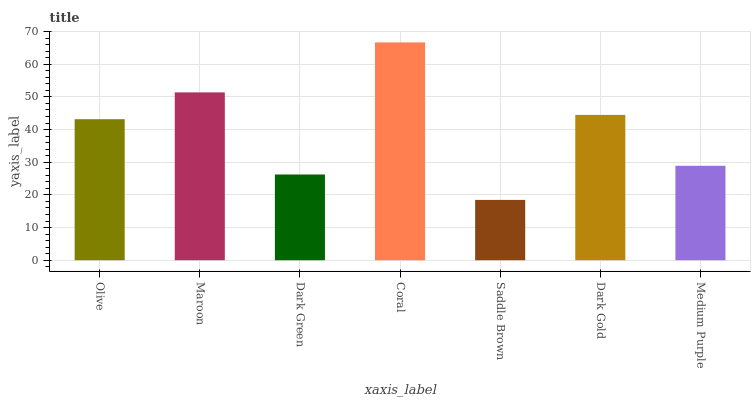Is Saddle Brown the minimum?
Answer yes or no. Yes. Is Coral the maximum?
Answer yes or no. Yes. Is Maroon the minimum?
Answer yes or no. No. Is Maroon the maximum?
Answer yes or no. No. Is Maroon greater than Olive?
Answer yes or no. Yes. Is Olive less than Maroon?
Answer yes or no. Yes. Is Olive greater than Maroon?
Answer yes or no. No. Is Maroon less than Olive?
Answer yes or no. No. Is Olive the high median?
Answer yes or no. Yes. Is Olive the low median?
Answer yes or no. Yes. Is Dark Gold the high median?
Answer yes or no. No. Is Coral the low median?
Answer yes or no. No. 